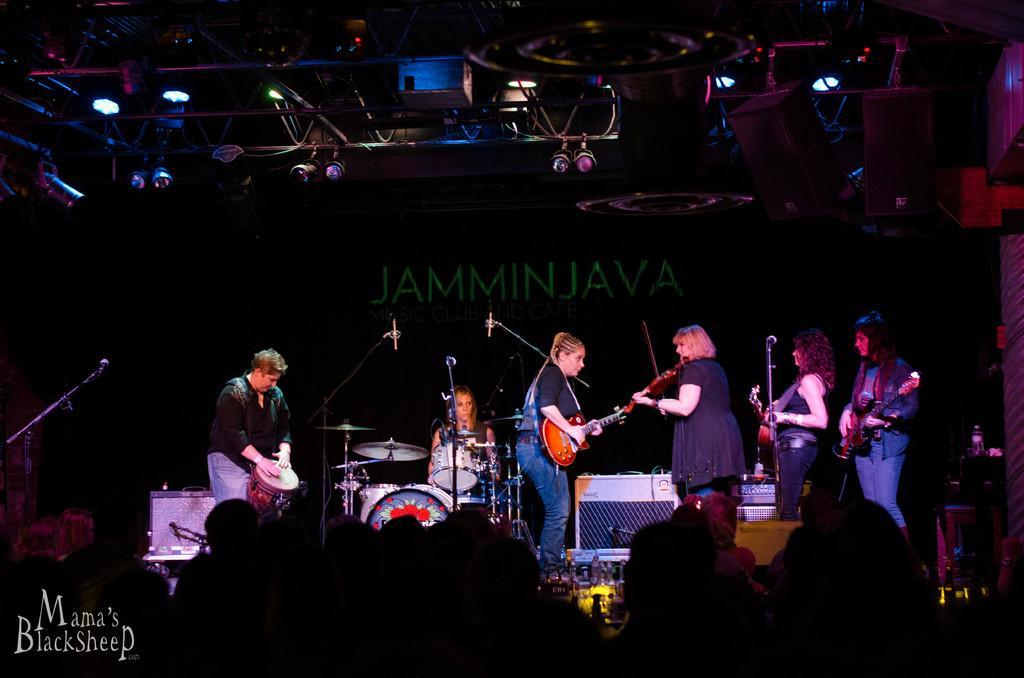Can you describe this image briefly? As we can see in the image there are group of people playing different types of musical instruments. 